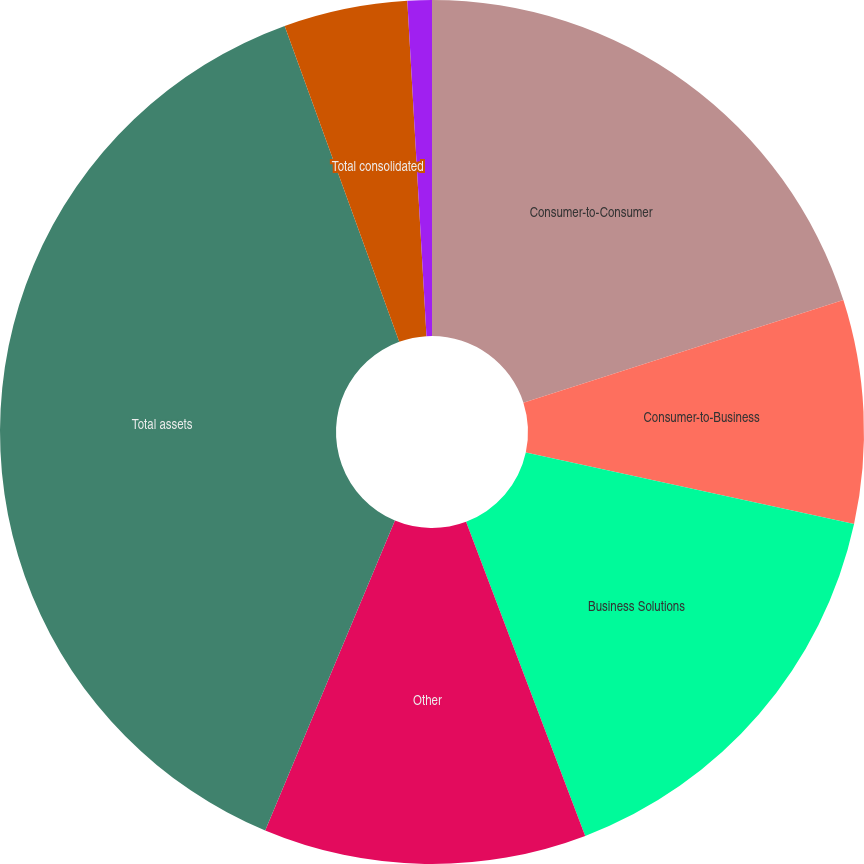<chart> <loc_0><loc_0><loc_500><loc_500><pie_chart><fcel>Consumer-to-Consumer<fcel>Consumer-to-Business<fcel>Business Solutions<fcel>Other<fcel>Total assets<fcel>Total consolidated<fcel>Total capital expenditures<nl><fcel>20.06%<fcel>8.36%<fcel>15.81%<fcel>12.08%<fcel>38.15%<fcel>4.63%<fcel>0.91%<nl></chart> 